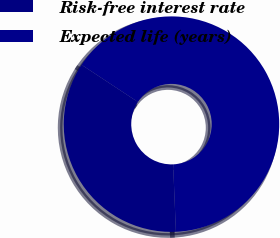Convert chart to OTSL. <chart><loc_0><loc_0><loc_500><loc_500><pie_chart><fcel>Risk-free interest rate<fcel>Expected life (years)<nl><fcel>34.94%<fcel>65.06%<nl></chart> 